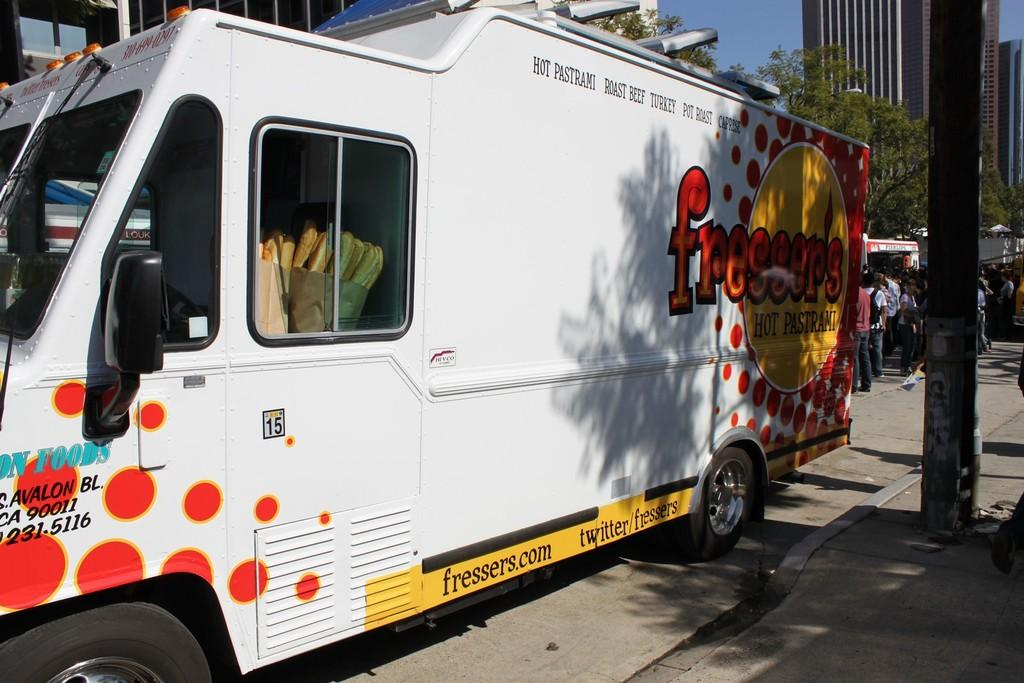Who or what can be seen in the image? There are people in the image. What else is present in the image besides the people? There are food items in a truck, texts on the truck, a pole, buildings, and the sky is visible in the image. How many cent-sized tanks are visible in the image? There are no tanks, cent-sized or otherwise, present in the image. 